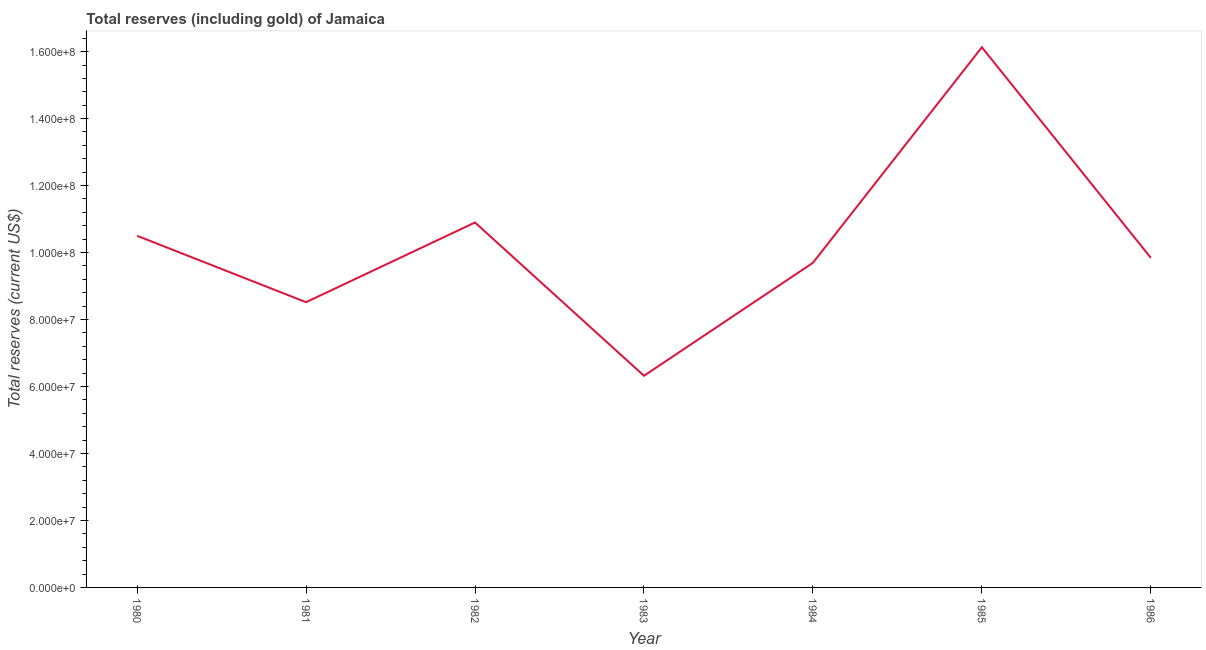What is the total reserves (including gold) in 1985?
Provide a succinct answer. 1.61e+08. Across all years, what is the maximum total reserves (including gold)?
Keep it short and to the point. 1.61e+08. Across all years, what is the minimum total reserves (including gold)?
Make the answer very short. 6.32e+07. In which year was the total reserves (including gold) maximum?
Give a very brief answer. 1985. In which year was the total reserves (including gold) minimum?
Make the answer very short. 1983. What is the sum of the total reserves (including gold)?
Make the answer very short. 7.19e+08. What is the difference between the total reserves (including gold) in 1982 and 1984?
Provide a succinct answer. 1.20e+07. What is the average total reserves (including gold) per year?
Your response must be concise. 1.03e+08. What is the median total reserves (including gold)?
Keep it short and to the point. 9.84e+07. What is the ratio of the total reserves (including gold) in 1985 to that in 1986?
Give a very brief answer. 1.64. Is the total reserves (including gold) in 1984 less than that in 1986?
Provide a succinct answer. Yes. What is the difference between the highest and the second highest total reserves (including gold)?
Offer a very short reply. 5.23e+07. What is the difference between the highest and the lowest total reserves (including gold)?
Make the answer very short. 9.81e+07. In how many years, is the total reserves (including gold) greater than the average total reserves (including gold) taken over all years?
Ensure brevity in your answer.  3. How many lines are there?
Ensure brevity in your answer.  1. Are the values on the major ticks of Y-axis written in scientific E-notation?
Keep it short and to the point. Yes. Does the graph contain any zero values?
Keep it short and to the point. No. What is the title of the graph?
Keep it short and to the point. Total reserves (including gold) of Jamaica. What is the label or title of the Y-axis?
Your response must be concise. Total reserves (current US$). What is the Total reserves (current US$) of 1980?
Your answer should be very brief. 1.05e+08. What is the Total reserves (current US$) of 1981?
Offer a very short reply. 8.52e+07. What is the Total reserves (current US$) in 1982?
Your answer should be compact. 1.09e+08. What is the Total reserves (current US$) of 1983?
Provide a succinct answer. 6.32e+07. What is the Total reserves (current US$) in 1984?
Your response must be concise. 9.69e+07. What is the Total reserves (current US$) of 1985?
Offer a terse response. 1.61e+08. What is the Total reserves (current US$) in 1986?
Ensure brevity in your answer.  9.84e+07. What is the difference between the Total reserves (current US$) in 1980 and 1981?
Make the answer very short. 1.98e+07. What is the difference between the Total reserves (current US$) in 1980 and 1982?
Your answer should be very brief. -3.97e+06. What is the difference between the Total reserves (current US$) in 1980 and 1983?
Your response must be concise. 4.18e+07. What is the difference between the Total reserves (current US$) in 1980 and 1984?
Offer a very short reply. 8.07e+06. What is the difference between the Total reserves (current US$) in 1980 and 1985?
Give a very brief answer. -5.63e+07. What is the difference between the Total reserves (current US$) in 1980 and 1986?
Give a very brief answer. 6.58e+06. What is the difference between the Total reserves (current US$) in 1981 and 1982?
Make the answer very short. -2.38e+07. What is the difference between the Total reserves (current US$) in 1981 and 1983?
Ensure brevity in your answer.  2.20e+07. What is the difference between the Total reserves (current US$) in 1981 and 1984?
Provide a short and direct response. -1.18e+07. What is the difference between the Total reserves (current US$) in 1981 and 1985?
Provide a succinct answer. -7.61e+07. What is the difference between the Total reserves (current US$) in 1981 and 1986?
Offer a very short reply. -1.32e+07. What is the difference between the Total reserves (current US$) in 1982 and 1983?
Your answer should be very brief. 4.58e+07. What is the difference between the Total reserves (current US$) in 1982 and 1984?
Ensure brevity in your answer.  1.20e+07. What is the difference between the Total reserves (current US$) in 1982 and 1985?
Your answer should be very brief. -5.23e+07. What is the difference between the Total reserves (current US$) in 1982 and 1986?
Offer a very short reply. 1.06e+07. What is the difference between the Total reserves (current US$) in 1983 and 1984?
Provide a succinct answer. -3.37e+07. What is the difference between the Total reserves (current US$) in 1983 and 1985?
Keep it short and to the point. -9.81e+07. What is the difference between the Total reserves (current US$) in 1983 and 1986?
Give a very brief answer. -3.52e+07. What is the difference between the Total reserves (current US$) in 1984 and 1985?
Your answer should be compact. -6.44e+07. What is the difference between the Total reserves (current US$) in 1984 and 1986?
Provide a succinct answer. -1.49e+06. What is the difference between the Total reserves (current US$) in 1985 and 1986?
Your response must be concise. 6.29e+07. What is the ratio of the Total reserves (current US$) in 1980 to that in 1981?
Make the answer very short. 1.23. What is the ratio of the Total reserves (current US$) in 1980 to that in 1982?
Ensure brevity in your answer.  0.96. What is the ratio of the Total reserves (current US$) in 1980 to that in 1983?
Your response must be concise. 1.66. What is the ratio of the Total reserves (current US$) in 1980 to that in 1984?
Offer a terse response. 1.08. What is the ratio of the Total reserves (current US$) in 1980 to that in 1985?
Offer a very short reply. 0.65. What is the ratio of the Total reserves (current US$) in 1980 to that in 1986?
Provide a short and direct response. 1.07. What is the ratio of the Total reserves (current US$) in 1981 to that in 1982?
Your answer should be very brief. 0.78. What is the ratio of the Total reserves (current US$) in 1981 to that in 1983?
Give a very brief answer. 1.35. What is the ratio of the Total reserves (current US$) in 1981 to that in 1984?
Your answer should be very brief. 0.88. What is the ratio of the Total reserves (current US$) in 1981 to that in 1985?
Offer a terse response. 0.53. What is the ratio of the Total reserves (current US$) in 1981 to that in 1986?
Your response must be concise. 0.86. What is the ratio of the Total reserves (current US$) in 1982 to that in 1983?
Your answer should be very brief. 1.72. What is the ratio of the Total reserves (current US$) in 1982 to that in 1984?
Your answer should be very brief. 1.12. What is the ratio of the Total reserves (current US$) in 1982 to that in 1985?
Offer a terse response. 0.68. What is the ratio of the Total reserves (current US$) in 1982 to that in 1986?
Your answer should be compact. 1.11. What is the ratio of the Total reserves (current US$) in 1983 to that in 1984?
Ensure brevity in your answer.  0.65. What is the ratio of the Total reserves (current US$) in 1983 to that in 1985?
Ensure brevity in your answer.  0.39. What is the ratio of the Total reserves (current US$) in 1983 to that in 1986?
Your answer should be compact. 0.64. What is the ratio of the Total reserves (current US$) in 1984 to that in 1985?
Your answer should be compact. 0.6. What is the ratio of the Total reserves (current US$) in 1985 to that in 1986?
Make the answer very short. 1.64. 